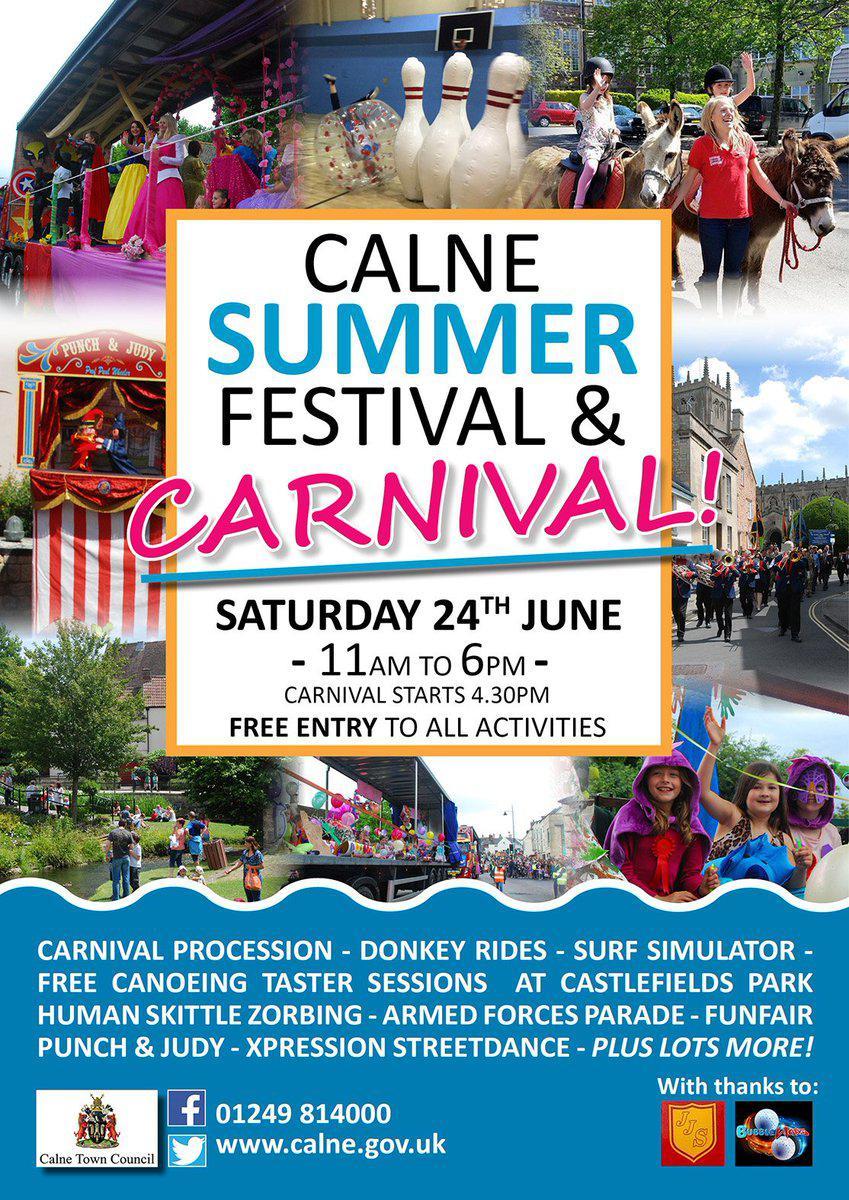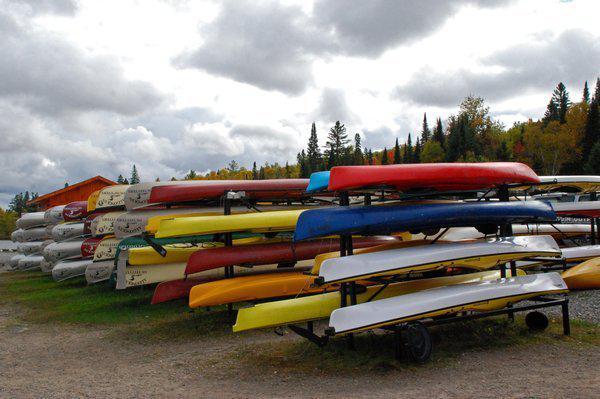The first image is the image on the left, the second image is the image on the right. Examine the images to the left and right. Is the description "There are at least six boats in the image on the right." accurate? Answer yes or no. Yes. 